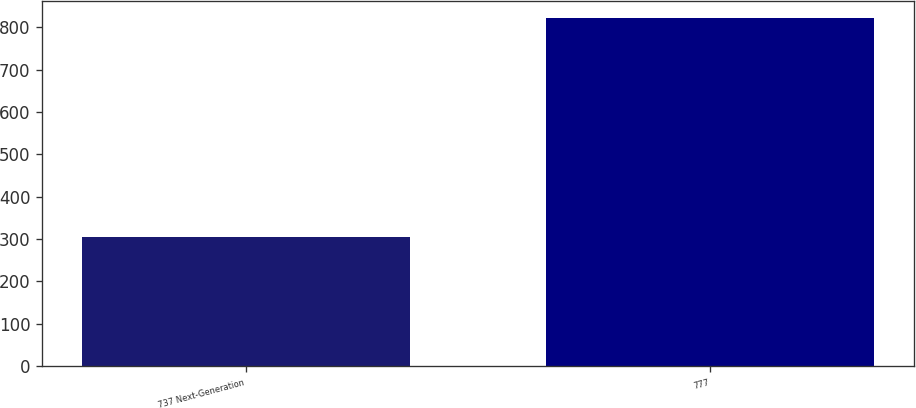Convert chart to OTSL. <chart><loc_0><loc_0><loc_500><loc_500><bar_chart><fcel>737 Next-Generation<fcel>777<nl><fcel>305<fcel>821<nl></chart> 